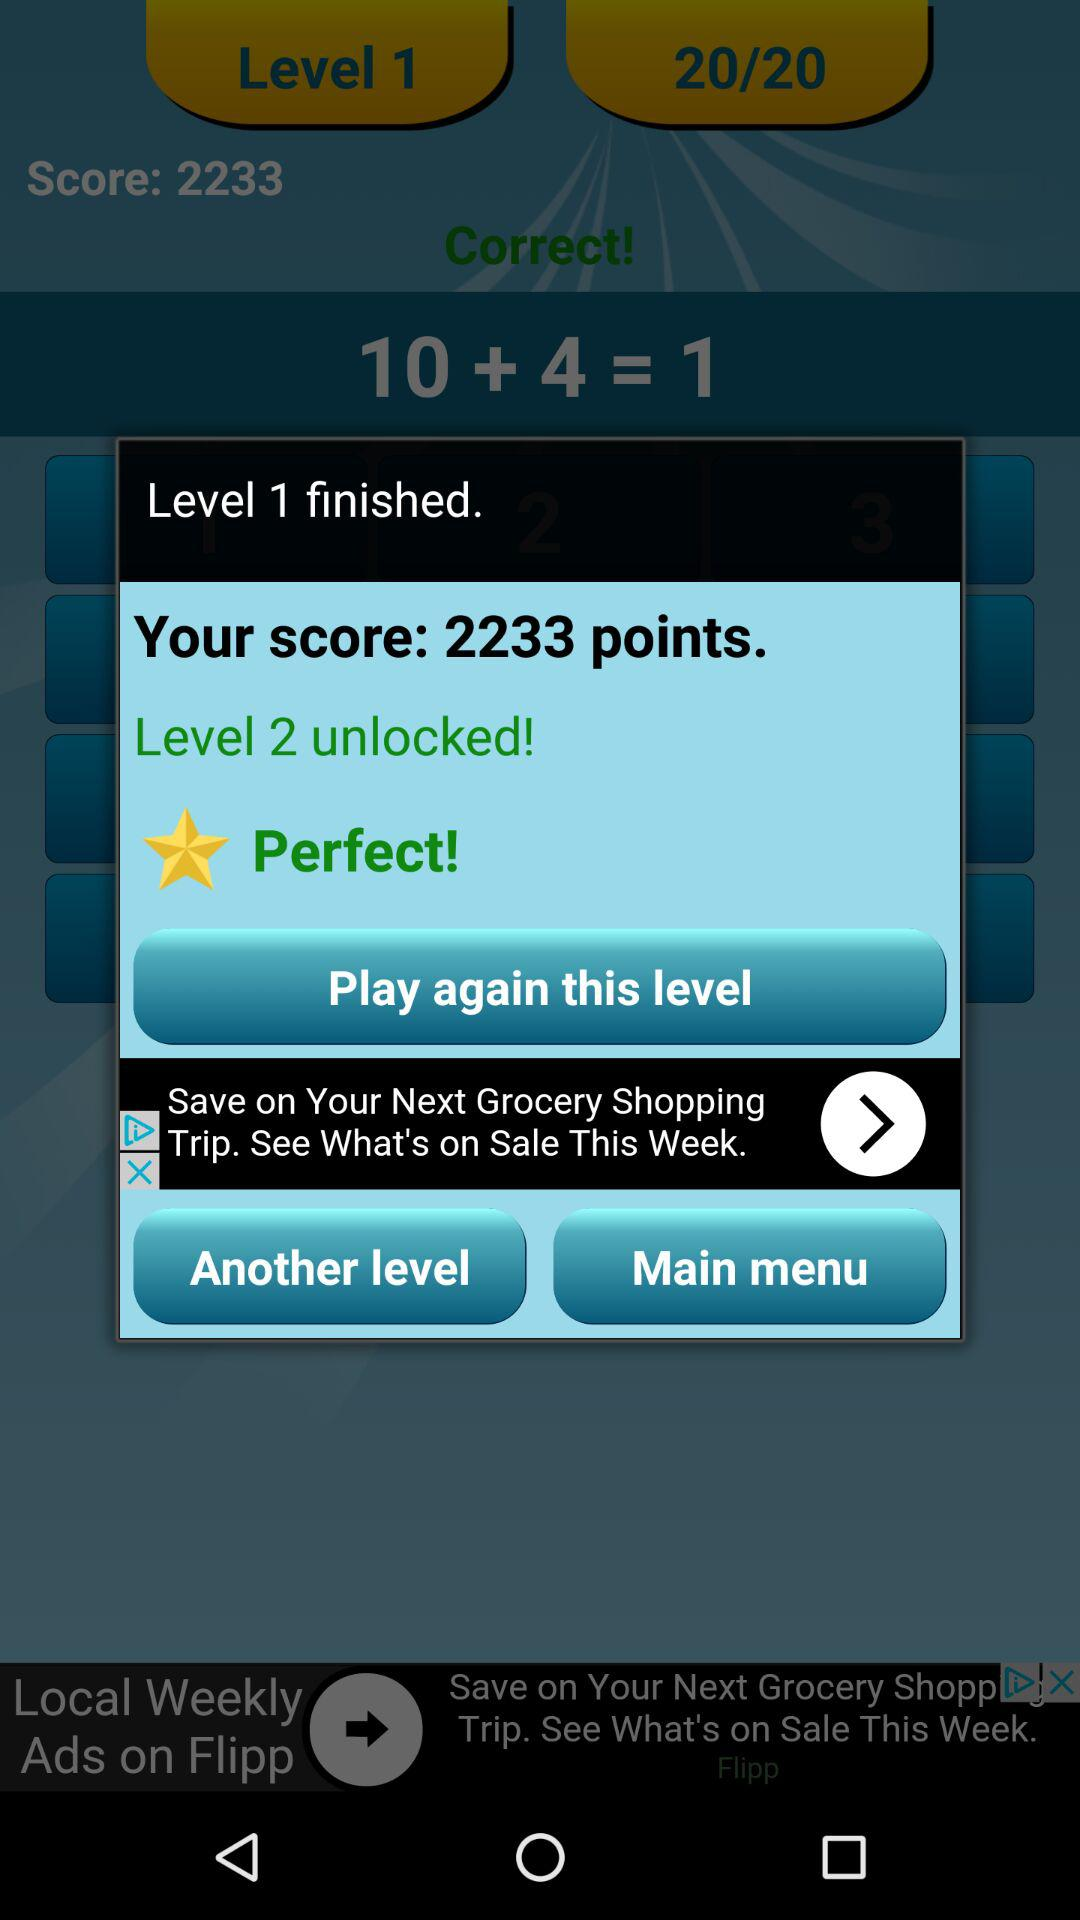How many points do I have?
Answer the question using a single word or phrase. 2233 